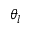Convert formula to latex. <formula><loc_0><loc_0><loc_500><loc_500>\theta _ { l }</formula> 